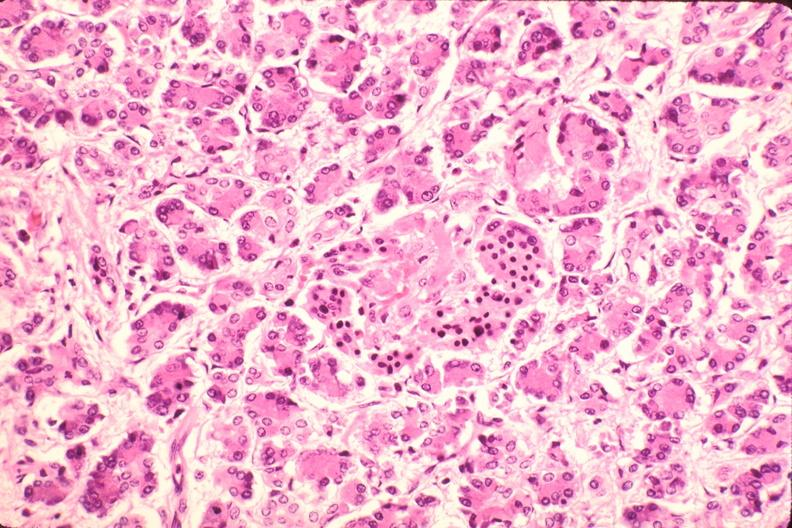where is this part in the figure?
Answer the question using a single word or phrase. Endocrine system 